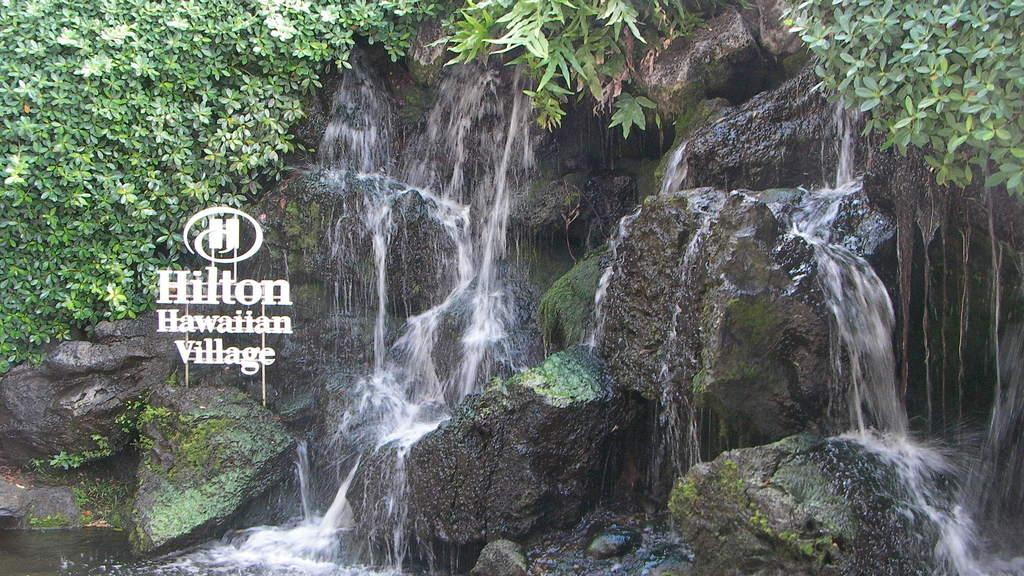What natural feature is the main subject of the image? There is a waterfall in the image. What can be seen in the background of the image? There are trees in the background of the image. What type of disease is affecting the family in the image? There is no family or disease present in the image; it features a waterfall and trees. 